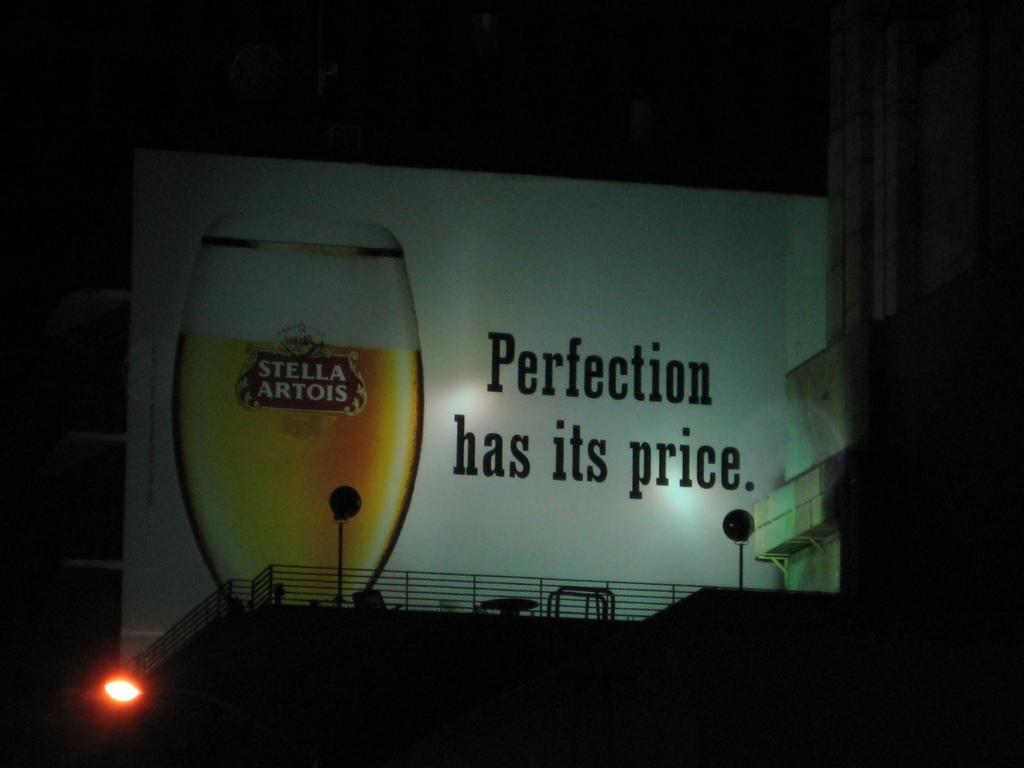What has its price?
Your response must be concise. Perfection. What brand is features?
Offer a terse response. Stella artois. 